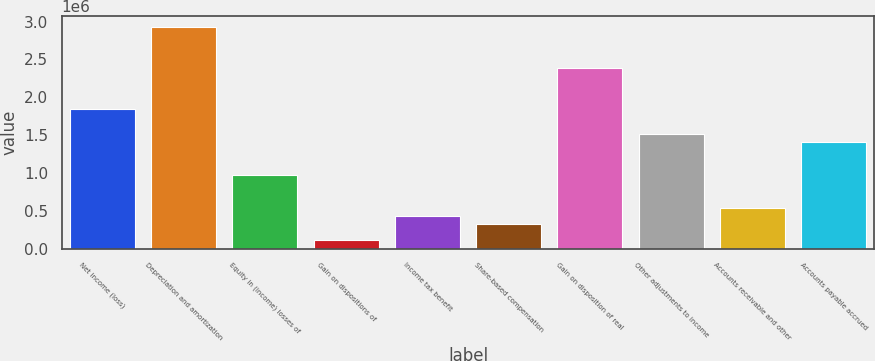Convert chart to OTSL. <chart><loc_0><loc_0><loc_500><loc_500><bar_chart><fcel>Net income (loss)<fcel>Depreciation and amortization<fcel>Equity in (income) losses of<fcel>Gain on dispositions of<fcel>Income tax benefit<fcel>Share-based compensation<fcel>Gain on disposition of real<fcel>Other adjustments to income<fcel>Accounts receivable and other<fcel>Accounts payable accrued<nl><fcel>1.84101e+06<fcel>2.92289e+06<fcel>975502<fcel>109994<fcel>434560<fcel>326371<fcel>2.38195e+06<fcel>1.51644e+06<fcel>542748<fcel>1.40826e+06<nl></chart> 